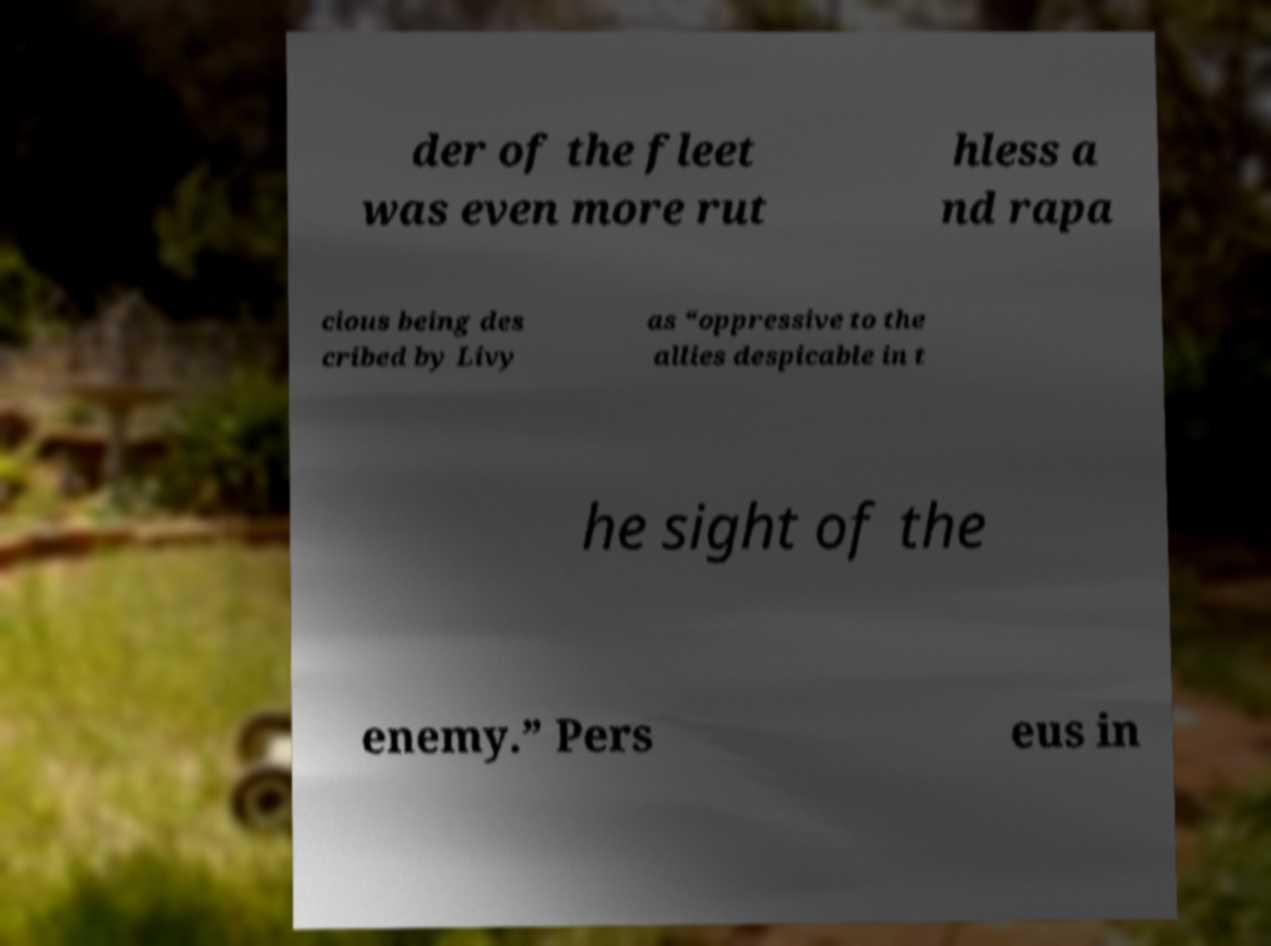Please identify and transcribe the text found in this image. der of the fleet was even more rut hless a nd rapa cious being des cribed by Livy as “oppressive to the allies despicable in t he sight of the enemy.” Pers eus in 